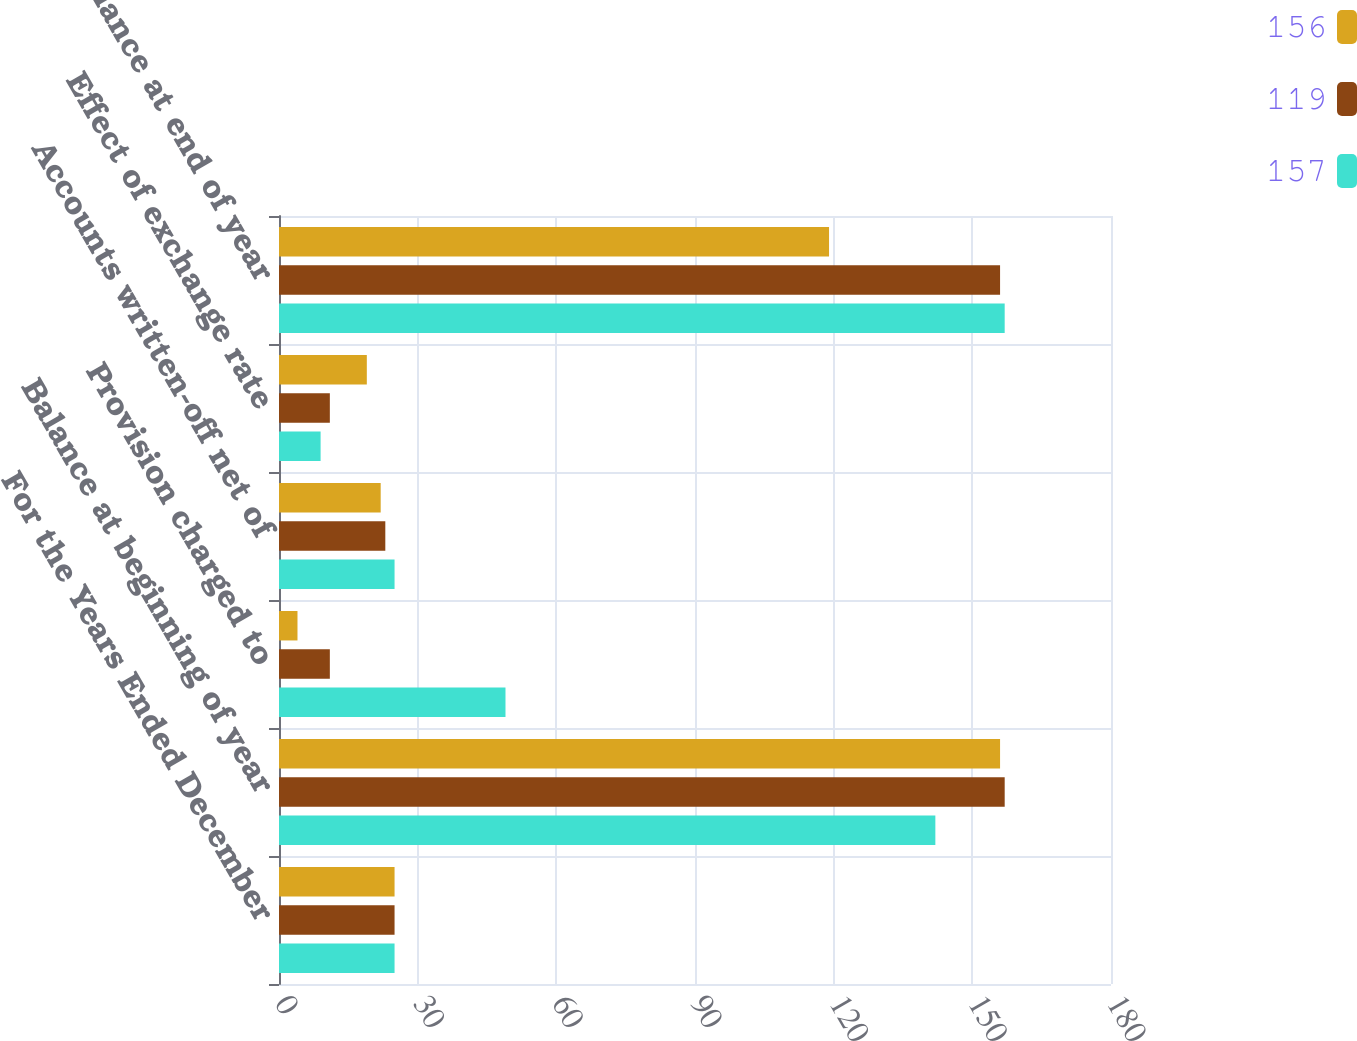<chart> <loc_0><loc_0><loc_500><loc_500><stacked_bar_chart><ecel><fcel>For the Years Ended December<fcel>Balance at beginning of year<fcel>Provision charged to<fcel>Accounts written-off net of<fcel>Effect of exchange rate<fcel>Balance at end of year<nl><fcel>156<fcel>25<fcel>156<fcel>4<fcel>22<fcel>19<fcel>119<nl><fcel>119<fcel>25<fcel>157<fcel>11<fcel>23<fcel>11<fcel>156<nl><fcel>157<fcel>25<fcel>142<fcel>49<fcel>25<fcel>9<fcel>157<nl></chart> 